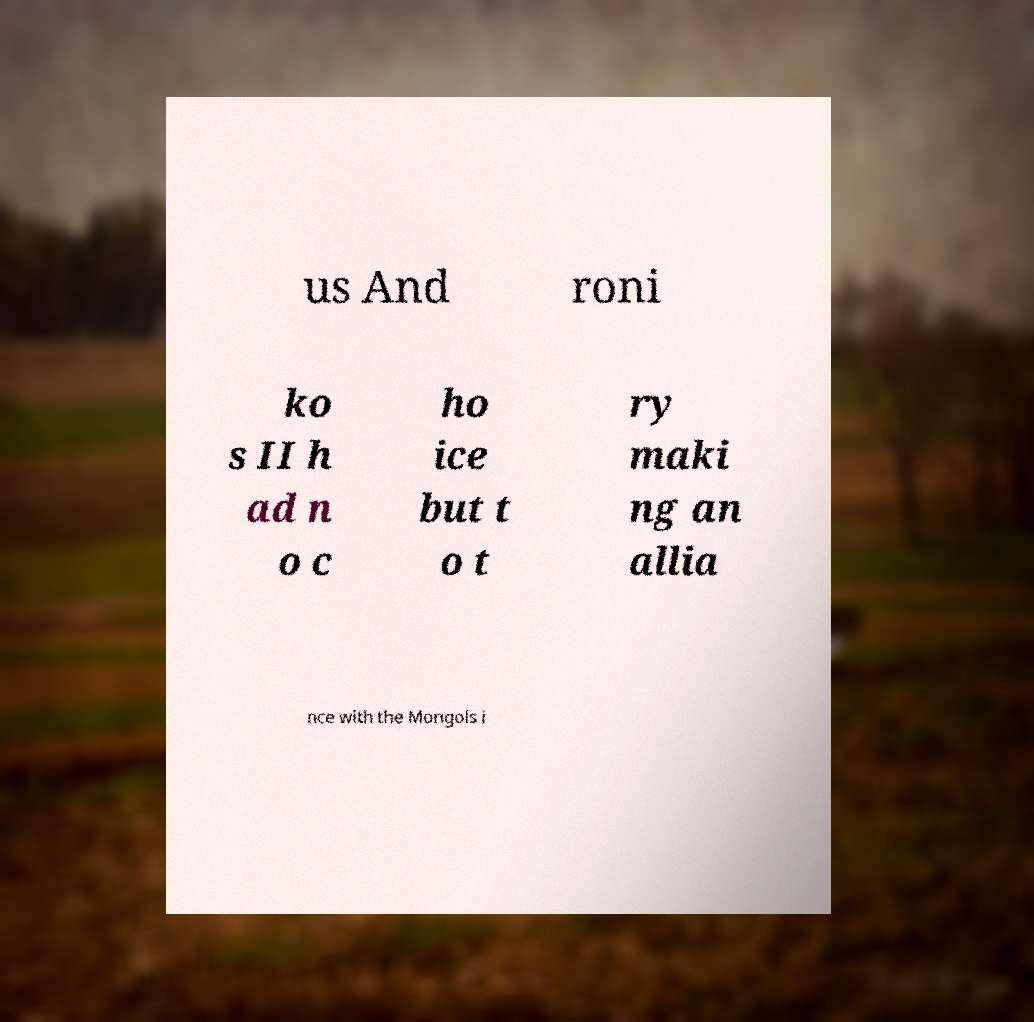Could you extract and type out the text from this image? us And roni ko s II h ad n o c ho ice but t o t ry maki ng an allia nce with the Mongols i 